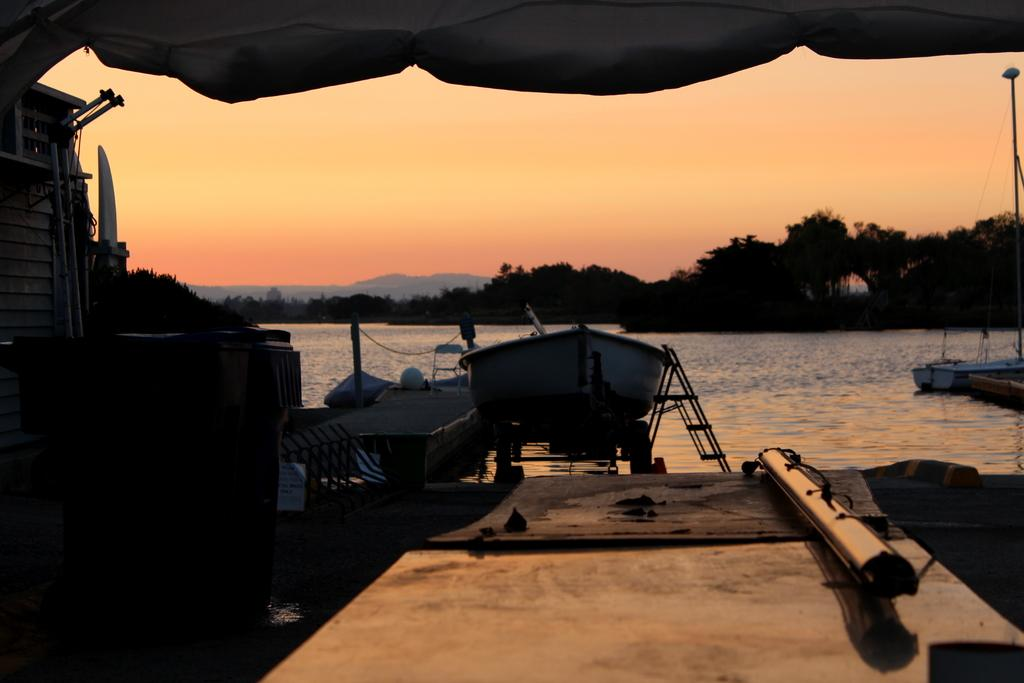What is the main subject of the image? The main subject of the image is a boat. Where is the boat located? The boat is on the water. What can be seen on the left side of the boat? There is a chair on the left side of the boat. What type of natural scenery is visible in the image? Trees, hills, and the sky are visible in the image. What type of apple is being used as a cannonball in the image? There is no apple or cannonball present in the image. What type of trousers is the person wearing while sitting on the chair in the image? There is no person visible in the image, so it is impossible to determine what type of trousers they might be wearing. 